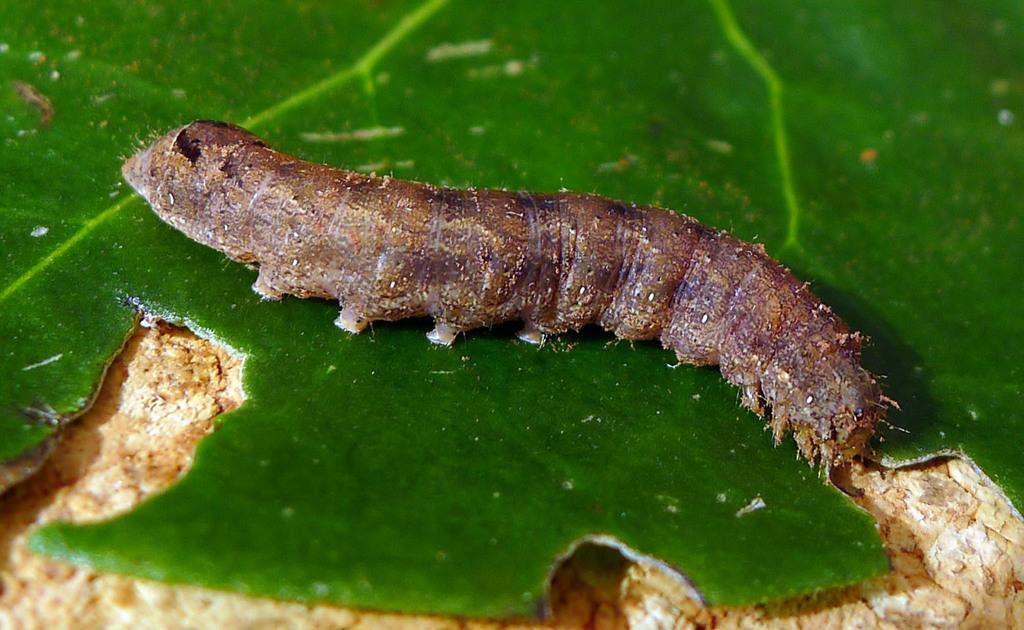What type of creature is in the image? There is an insect in the image, which appears to be a caterpillar. What is the caterpillar resting on in the image? The caterpillar is on a green leaf. Can you describe the item visible in the foreground of the image? Unfortunately, the facts provided do not give any information about the item in the foreground. What type of grain is visible in the image? There is no grain present in the image; it features a caterpillar on a green leaf. What act is the caterpillar performing in the image? The caterpillar is not performing any act in the image; it is simply resting on a green leaf. 